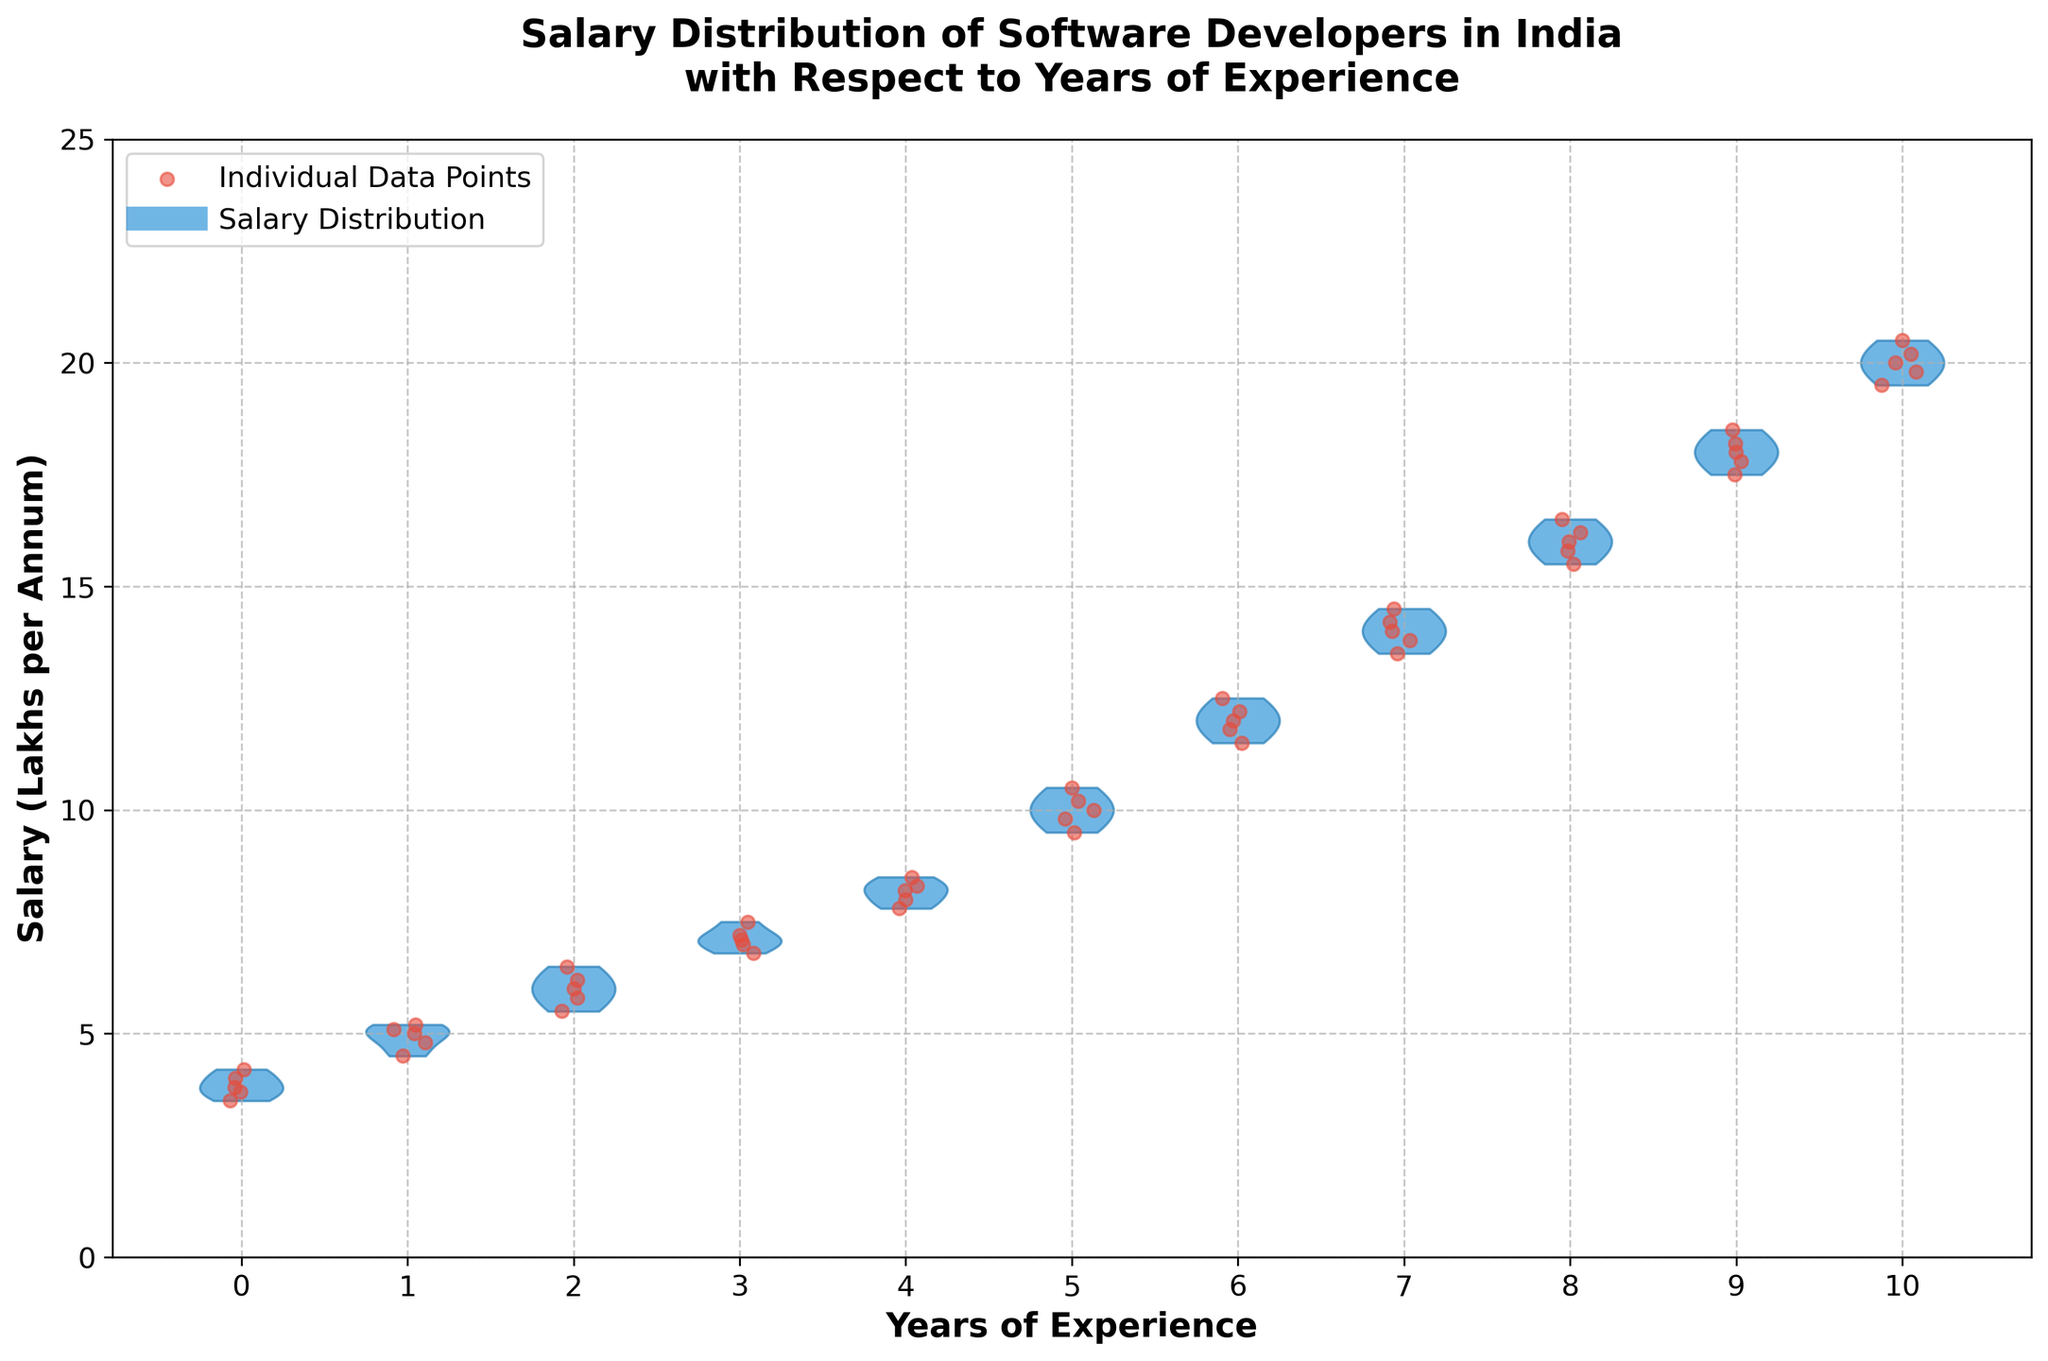What is the title of the plot? The title of the plot is displayed at the top and summarizes what the plot is about.
Answer: Salary Distribution of Software Developers in India with Respect to Years of Experience What does the x-axis represent? The x-axis represents the number of years of experience of software developers.
Answer: Years of Experience How many years of experiences are displayed in the plot? Count the number of unique tick marks on the x-axis.
Answer: 11 What does the y-axis represent? The y-axis represents the salary in lakhs per annum of the software developers.
Answer: Salary (Lakhs per Annum) Which year of experience has the highest average salary distribution? Examine the violin plots to determine which one extends the highest on the y-axis.
Answer: 10 years What is the range of salaries for developers with 5 years of experience? Look at the extent of the violin plot for 5 years on the y-axis.
Answer: Approximately 9.5 to 10.5 lakhs per annum For which year of experience do we observe the highest individual salary? Find the point on the scatter that is the highest on the y-axis.
Answer: 10 years Does the average salary tend to increase with years of experience? Observe the trend in the median points and the overall shape of the violin plots as the years of experience increase.
Answer: Yes Which year of experience shows the most tightly clustered salary values? Identify the violin plot with the narrowest distribution.
Answer: 5 years How does salary variability change as experience increases from 0 to 10 years? Compare the width of the violin plots starting from 0 years to 10 years of experience.
Answer: Increases 